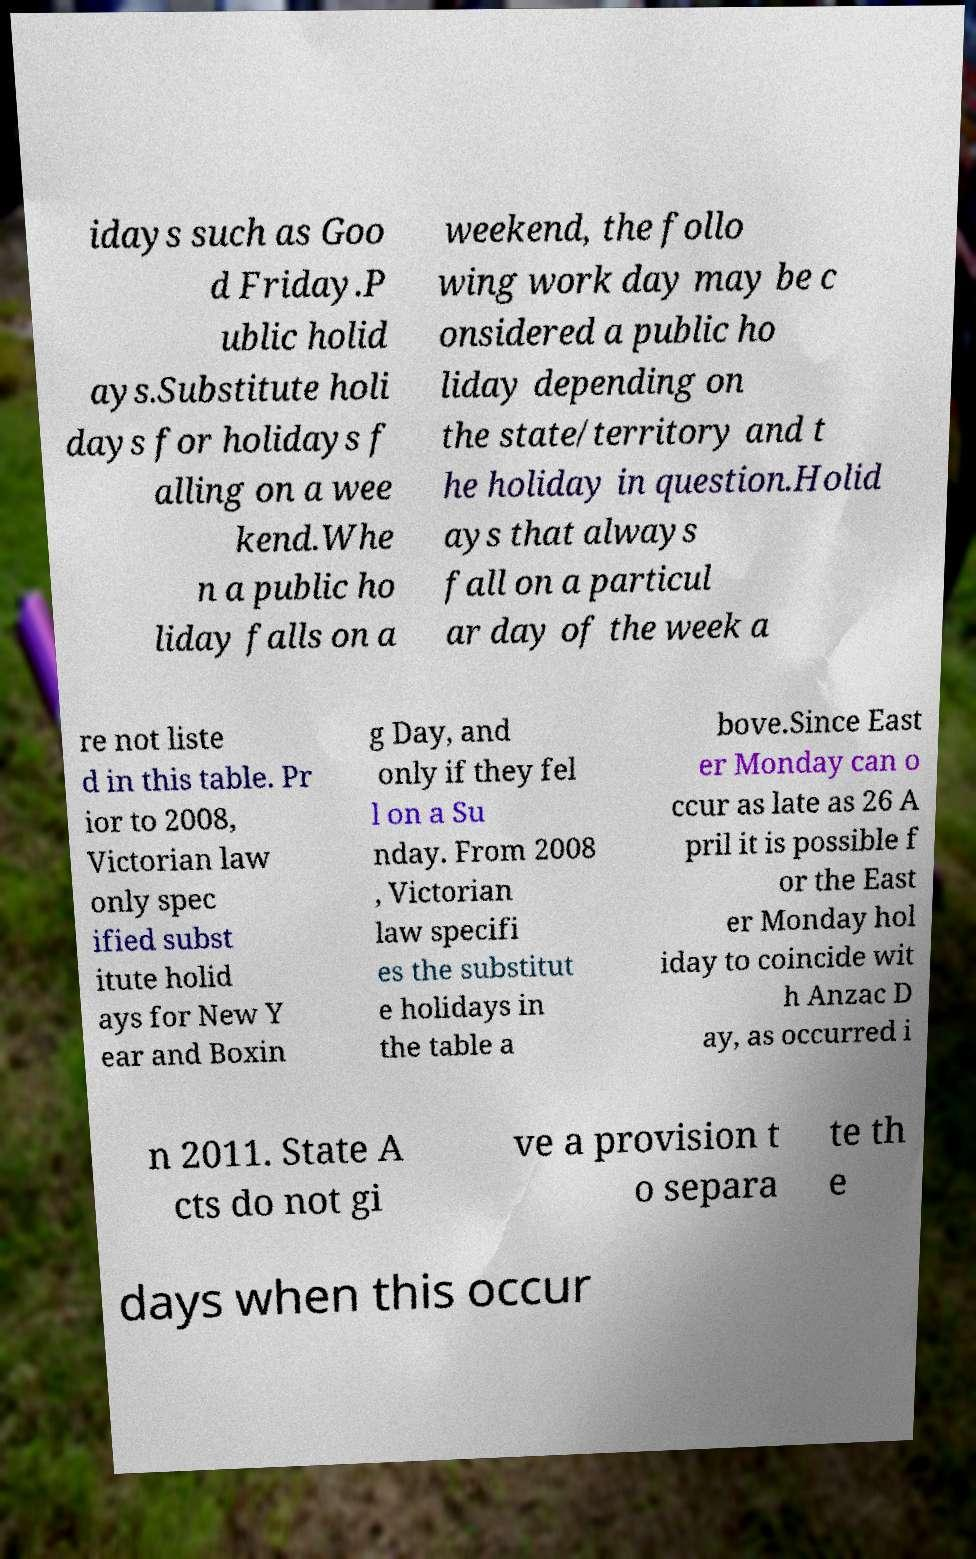Can you read and provide the text displayed in the image?This photo seems to have some interesting text. Can you extract and type it out for me? idays such as Goo d Friday.P ublic holid ays.Substitute holi days for holidays f alling on a wee kend.Whe n a public ho liday falls on a weekend, the follo wing work day may be c onsidered a public ho liday depending on the state/territory and t he holiday in question.Holid ays that always fall on a particul ar day of the week a re not liste d in this table. Pr ior to 2008, Victorian law only spec ified subst itute holid ays for New Y ear and Boxin g Day, and only if they fel l on a Su nday. From 2008 , Victorian law specifi es the substitut e holidays in the table a bove.Since East er Monday can o ccur as late as 26 A pril it is possible f or the East er Monday hol iday to coincide wit h Anzac D ay, as occurred i n 2011. State A cts do not gi ve a provision t o separa te th e days when this occur 